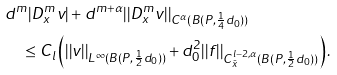<formula> <loc_0><loc_0><loc_500><loc_500>& d ^ { m } | D ^ { m } _ { x } v | + d ^ { m + \alpha } | | D ^ { m } _ { x } v | | _ { C ^ { \alpha } ( B ( P , \frac { 1 } { 4 } d _ { 0 } ) ) } \\ & \quad \leq C _ { l } \left ( | | v | | _ { L ^ { \infty } ( B ( P , \frac { 1 } { 2 } d _ { 0 } ) ) } + d _ { 0 } ^ { 2 } | | f | | _ { C ^ { l - 2 , \alpha } _ { \bar { x } } ( B ( P , \frac { 1 } { 2 } d _ { 0 } ) ) } \right ) .</formula> 